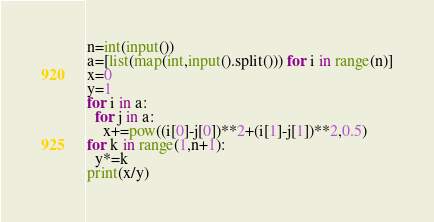Convert code to text. <code><loc_0><loc_0><loc_500><loc_500><_Python_>n=int(input())
a=[list(map(int,input().split())) for i in range(n)]
x=0
y=1
for i in a:
  for j in a:
    x+=pow((i[0]-j[0])**2+(i[1]-j[1])**2,0.5)
for k in range(1,n+1):
  y*=k
print(x/y)</code> 